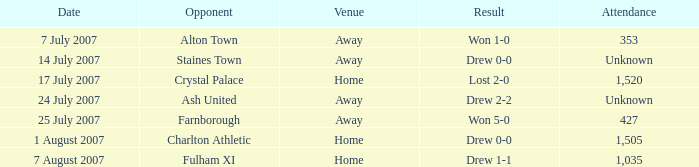Share the date when the triumph was 1- 7 July 2007. 